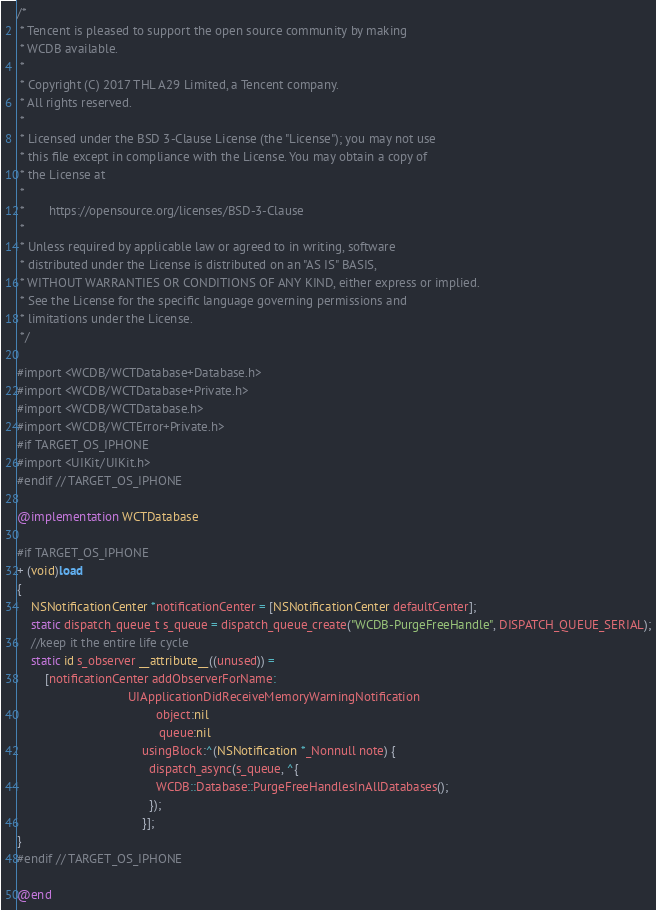Convert code to text. <code><loc_0><loc_0><loc_500><loc_500><_ObjectiveC_>/*
 * Tencent is pleased to support the open source community by making
 * WCDB available.
 *
 * Copyright (C) 2017 THL A29 Limited, a Tencent company.
 * All rights reserved.
 *
 * Licensed under the BSD 3-Clause License (the "License"); you may not use
 * this file except in compliance with the License. You may obtain a copy of
 * the License at
 *
 *       https://opensource.org/licenses/BSD-3-Clause
 *
 * Unless required by applicable law or agreed to in writing, software
 * distributed under the License is distributed on an "AS IS" BASIS,
 * WITHOUT WARRANTIES OR CONDITIONS OF ANY KIND, either express or implied.
 * See the License for the specific language governing permissions and
 * limitations under the License.
 */

#import <WCDB/WCTDatabase+Database.h>
#import <WCDB/WCTDatabase+Private.h>
#import <WCDB/WCTDatabase.h>
#import <WCDB/WCTError+Private.h>
#if TARGET_OS_IPHONE
#import <UIKit/UIKit.h>
#endif // TARGET_OS_IPHONE

@implementation WCTDatabase

#if TARGET_OS_IPHONE
+ (void)load
{
    NSNotificationCenter *notificationCenter = [NSNotificationCenter defaultCenter];
    static dispatch_queue_t s_queue = dispatch_queue_create("WCDB-PurgeFreeHandle", DISPATCH_QUEUE_SERIAL);
    //keep it the entire life cycle
    static id s_observer __attribute__((unused)) =
        [notificationCenter addObserverForName:
                                UIApplicationDidReceiveMemoryWarningNotification
                                        object:nil
                                         queue:nil
                                    usingBlock:^(NSNotification *_Nonnull note) {
                                      dispatch_async(s_queue, ^{
                                        WCDB::Database::PurgeFreeHandlesInAllDatabases();
                                      });
                                    }];
}
#endif // TARGET_OS_IPHONE

@end
</code> 